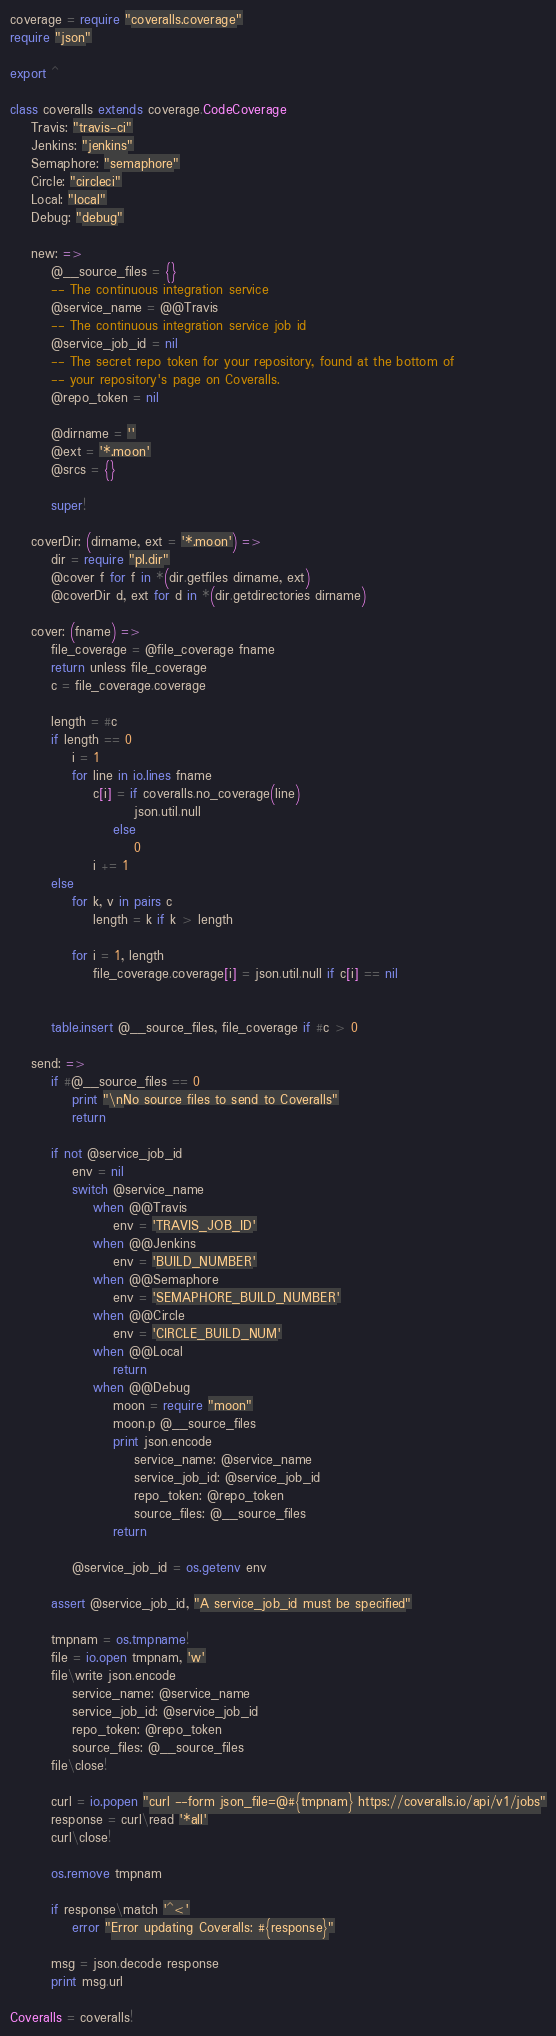<code> <loc_0><loc_0><loc_500><loc_500><_MoonScript_>coverage = require "coveralls.coverage"
require "json"

export ^

class coveralls extends coverage.CodeCoverage
	Travis: "travis-ci"
	Jenkins: "jenkins"
	Semaphore: "semaphore"
	Circle: "circleci"
	Local: "local"
	Debug: "debug"

	new: =>
		@__source_files = {}
		-- The continuous integration service
		@service_name = @@Travis
		-- The continuous integration service job id
		@service_job_id = nil
		-- The secret repo token for your repository, found at the bottom of
		-- your repository's page on Coveralls.
		@repo_token = nil

		@dirname = ''
		@ext = '*.moon'
		@srcs = {}

		super!

	coverDir: (dirname, ext = '*.moon') =>
		dir = require "pl.dir"
		@cover f for f in *(dir.getfiles dirname, ext)
		@coverDir d, ext for d in *(dir.getdirectories dirname)

	cover: (fname) =>
		file_coverage = @file_coverage fname
		return unless file_coverage
		c = file_coverage.coverage

		length = #c
		if length == 0
			i = 1
			for line in io.lines fname
				c[i] = if coveralls.no_coverage(line)
						json.util.null
					else
						0
				i += 1
		else
			for k, v in pairs c
				length = k if k > length

			for i = 1, length
				file_coverage.coverage[i] = json.util.null if c[i] == nil


		table.insert @__source_files, file_coverage if #c > 0

	send: =>
		if #@__source_files == 0
			print "\nNo source files to send to Coveralls"
			return

		if not @service_job_id
			env = nil
			switch @service_name
				when @@Travis
					env = 'TRAVIS_JOB_ID'
				when @@Jenkins
					env = 'BUILD_NUMBER'
				when @@Semaphore
					env = 'SEMAPHORE_BUILD_NUMBER'
				when @@Circle
					env = 'CIRCLE_BUILD_NUM'
				when @@Local
					return
				when @@Debug
					moon = require "moon"
					moon.p @__source_files
					print json.encode
						service_name: @service_name
						service_job_id: @service_job_id
						repo_token: @repo_token
						source_files: @__source_files
					return

			@service_job_id = os.getenv env

		assert @service_job_id, "A service_job_id must be specified"

		tmpnam = os.tmpname!
		file = io.open tmpnam, 'w'
		file\write json.encode
			service_name: @service_name
			service_job_id: @service_job_id
			repo_token: @repo_token
			source_files: @__source_files
		file\close!

		curl = io.popen "curl --form json_file=@#{tmpnam} https://coveralls.io/api/v1/jobs"
		response = curl\read '*all'
		curl\close!

		os.remove tmpnam

		if response\match '^<'
			error "Error updating Coveralls: #{response}"

		msg = json.decode response
		print msg.url

Coveralls = coveralls!
</code> 